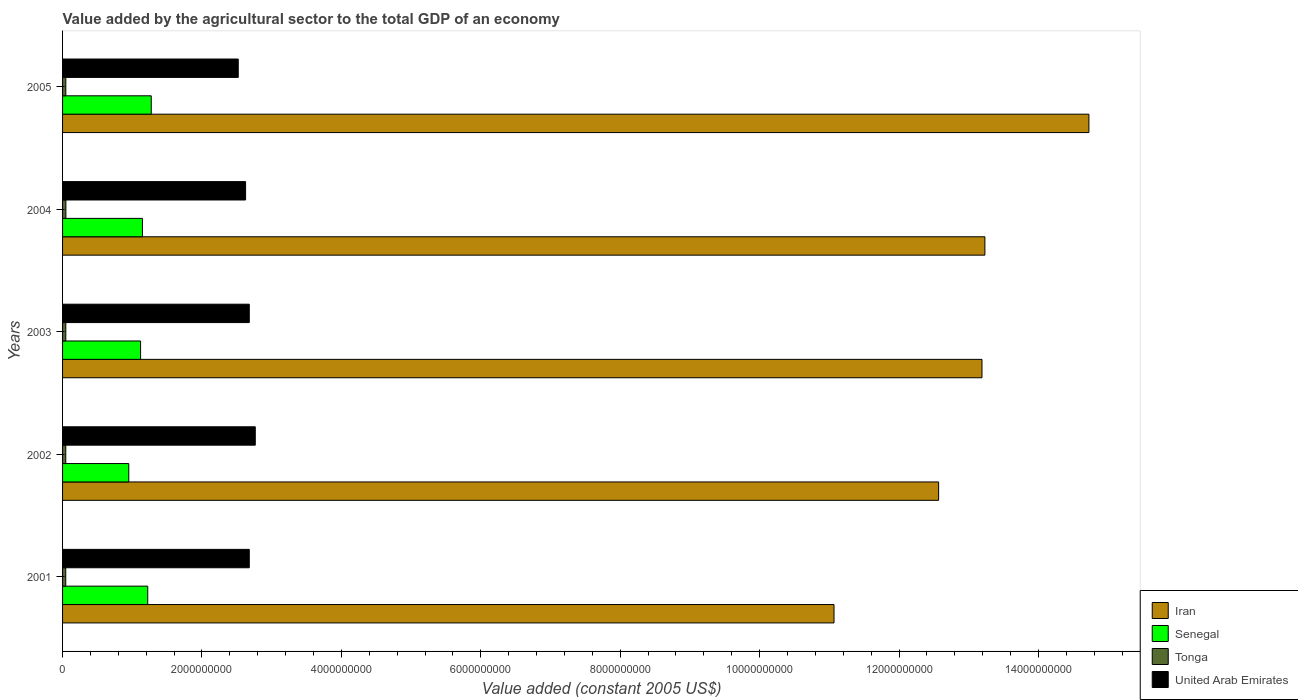How many different coloured bars are there?
Offer a very short reply. 4. Are the number of bars on each tick of the Y-axis equal?
Offer a terse response. Yes. What is the value added by the agricultural sector in United Arab Emirates in 2005?
Your response must be concise. 2.52e+09. Across all years, what is the maximum value added by the agricultural sector in Tonga?
Give a very brief answer. 4.76e+07. Across all years, what is the minimum value added by the agricultural sector in Iran?
Keep it short and to the point. 1.11e+1. In which year was the value added by the agricultural sector in Tonga maximum?
Give a very brief answer. 2004. In which year was the value added by the agricultural sector in Iran minimum?
Provide a succinct answer. 2001. What is the total value added by the agricultural sector in Iran in the graph?
Your answer should be compact. 6.48e+1. What is the difference between the value added by the agricultural sector in Senegal in 2003 and that in 2004?
Ensure brevity in your answer.  -2.67e+07. What is the difference between the value added by the agricultural sector in Senegal in 2005 and the value added by the agricultural sector in Iran in 2002?
Ensure brevity in your answer.  -1.13e+1. What is the average value added by the agricultural sector in Tonga per year?
Offer a very short reply. 4.65e+07. In the year 2001, what is the difference between the value added by the agricultural sector in Iran and value added by the agricultural sector in Tonga?
Provide a short and direct response. 1.10e+1. What is the ratio of the value added by the agricultural sector in Tonga in 2001 to that in 2002?
Your answer should be very brief. 0.99. What is the difference between the highest and the second highest value added by the agricultural sector in Iran?
Provide a succinct answer. 1.49e+09. What is the difference between the highest and the lowest value added by the agricultural sector in Tonga?
Provide a succinct answer. 1.84e+06. What does the 3rd bar from the top in 2004 represents?
Offer a very short reply. Senegal. What does the 1st bar from the bottom in 2004 represents?
Ensure brevity in your answer.  Iran. What is the difference between two consecutive major ticks on the X-axis?
Give a very brief answer. 2.00e+09. Are the values on the major ticks of X-axis written in scientific E-notation?
Offer a terse response. No. Does the graph contain any zero values?
Your response must be concise. No. Does the graph contain grids?
Ensure brevity in your answer.  No. How many legend labels are there?
Offer a very short reply. 4. How are the legend labels stacked?
Ensure brevity in your answer.  Vertical. What is the title of the graph?
Offer a terse response. Value added by the agricultural sector to the total GDP of an economy. Does "Ecuador" appear as one of the legend labels in the graph?
Ensure brevity in your answer.  No. What is the label or title of the X-axis?
Ensure brevity in your answer.  Value added (constant 2005 US$). What is the Value added (constant 2005 US$) of Iran in 2001?
Provide a short and direct response. 1.11e+1. What is the Value added (constant 2005 US$) of Senegal in 2001?
Your answer should be compact. 1.22e+09. What is the Value added (constant 2005 US$) in Tonga in 2001?
Your response must be concise. 4.58e+07. What is the Value added (constant 2005 US$) in United Arab Emirates in 2001?
Your response must be concise. 2.68e+09. What is the Value added (constant 2005 US$) in Iran in 2002?
Ensure brevity in your answer.  1.26e+1. What is the Value added (constant 2005 US$) in Senegal in 2002?
Make the answer very short. 9.50e+08. What is the Value added (constant 2005 US$) of Tonga in 2002?
Provide a succinct answer. 4.61e+07. What is the Value added (constant 2005 US$) in United Arab Emirates in 2002?
Make the answer very short. 2.76e+09. What is the Value added (constant 2005 US$) of Iran in 2003?
Offer a very short reply. 1.32e+1. What is the Value added (constant 2005 US$) of Senegal in 2003?
Your answer should be very brief. 1.12e+09. What is the Value added (constant 2005 US$) in Tonga in 2003?
Provide a short and direct response. 4.66e+07. What is the Value added (constant 2005 US$) in United Arab Emirates in 2003?
Ensure brevity in your answer.  2.68e+09. What is the Value added (constant 2005 US$) in Iran in 2004?
Keep it short and to the point. 1.32e+1. What is the Value added (constant 2005 US$) of Senegal in 2004?
Offer a very short reply. 1.15e+09. What is the Value added (constant 2005 US$) of Tonga in 2004?
Ensure brevity in your answer.  4.76e+07. What is the Value added (constant 2005 US$) of United Arab Emirates in 2004?
Offer a very short reply. 2.63e+09. What is the Value added (constant 2005 US$) in Iran in 2005?
Your response must be concise. 1.47e+1. What is the Value added (constant 2005 US$) in Senegal in 2005?
Provide a succinct answer. 1.27e+09. What is the Value added (constant 2005 US$) in Tonga in 2005?
Offer a very short reply. 4.66e+07. What is the Value added (constant 2005 US$) of United Arab Emirates in 2005?
Make the answer very short. 2.52e+09. Across all years, what is the maximum Value added (constant 2005 US$) of Iran?
Your answer should be compact. 1.47e+1. Across all years, what is the maximum Value added (constant 2005 US$) of Senegal?
Your response must be concise. 1.27e+09. Across all years, what is the maximum Value added (constant 2005 US$) of Tonga?
Your response must be concise. 4.76e+07. Across all years, what is the maximum Value added (constant 2005 US$) of United Arab Emirates?
Make the answer very short. 2.76e+09. Across all years, what is the minimum Value added (constant 2005 US$) of Iran?
Ensure brevity in your answer.  1.11e+1. Across all years, what is the minimum Value added (constant 2005 US$) in Senegal?
Provide a short and direct response. 9.50e+08. Across all years, what is the minimum Value added (constant 2005 US$) in Tonga?
Provide a succinct answer. 4.58e+07. Across all years, what is the minimum Value added (constant 2005 US$) in United Arab Emirates?
Provide a succinct answer. 2.52e+09. What is the total Value added (constant 2005 US$) of Iran in the graph?
Provide a succinct answer. 6.48e+1. What is the total Value added (constant 2005 US$) of Senegal in the graph?
Your answer should be compact. 5.71e+09. What is the total Value added (constant 2005 US$) in Tonga in the graph?
Provide a succinct answer. 2.33e+08. What is the total Value added (constant 2005 US$) of United Arab Emirates in the graph?
Keep it short and to the point. 1.33e+1. What is the difference between the Value added (constant 2005 US$) of Iran in 2001 and that in 2002?
Provide a short and direct response. -1.50e+09. What is the difference between the Value added (constant 2005 US$) of Senegal in 2001 and that in 2002?
Offer a terse response. 2.72e+08. What is the difference between the Value added (constant 2005 US$) of Tonga in 2001 and that in 2002?
Your response must be concise. -3.43e+05. What is the difference between the Value added (constant 2005 US$) in United Arab Emirates in 2001 and that in 2002?
Keep it short and to the point. -8.60e+07. What is the difference between the Value added (constant 2005 US$) of Iran in 2001 and that in 2003?
Your answer should be very brief. -2.12e+09. What is the difference between the Value added (constant 2005 US$) of Senegal in 2001 and that in 2003?
Provide a succinct answer. 1.02e+08. What is the difference between the Value added (constant 2005 US$) in Tonga in 2001 and that in 2003?
Offer a very short reply. -8.05e+05. What is the difference between the Value added (constant 2005 US$) in Iran in 2001 and that in 2004?
Give a very brief answer. -2.16e+09. What is the difference between the Value added (constant 2005 US$) of Senegal in 2001 and that in 2004?
Give a very brief answer. 7.58e+07. What is the difference between the Value added (constant 2005 US$) in Tonga in 2001 and that in 2004?
Offer a terse response. -1.84e+06. What is the difference between the Value added (constant 2005 US$) of United Arab Emirates in 2001 and that in 2004?
Make the answer very short. 5.28e+07. What is the difference between the Value added (constant 2005 US$) of Iran in 2001 and that in 2005?
Your answer should be compact. -3.66e+09. What is the difference between the Value added (constant 2005 US$) in Senegal in 2001 and that in 2005?
Give a very brief answer. -5.05e+07. What is the difference between the Value added (constant 2005 US$) of Tonga in 2001 and that in 2005?
Provide a succinct answer. -8.19e+05. What is the difference between the Value added (constant 2005 US$) in United Arab Emirates in 2001 and that in 2005?
Your answer should be very brief. 1.58e+08. What is the difference between the Value added (constant 2005 US$) of Iran in 2002 and that in 2003?
Offer a terse response. -6.22e+08. What is the difference between the Value added (constant 2005 US$) of Senegal in 2002 and that in 2003?
Your answer should be compact. -1.69e+08. What is the difference between the Value added (constant 2005 US$) in Tonga in 2002 and that in 2003?
Provide a succinct answer. -4.62e+05. What is the difference between the Value added (constant 2005 US$) in United Arab Emirates in 2002 and that in 2003?
Offer a terse response. 8.60e+07. What is the difference between the Value added (constant 2005 US$) in Iran in 2002 and that in 2004?
Your answer should be compact. -6.64e+08. What is the difference between the Value added (constant 2005 US$) of Senegal in 2002 and that in 2004?
Keep it short and to the point. -1.96e+08. What is the difference between the Value added (constant 2005 US$) in Tonga in 2002 and that in 2004?
Give a very brief answer. -1.49e+06. What is the difference between the Value added (constant 2005 US$) of United Arab Emirates in 2002 and that in 2004?
Provide a succinct answer. 1.39e+08. What is the difference between the Value added (constant 2005 US$) in Iran in 2002 and that in 2005?
Keep it short and to the point. -2.16e+09. What is the difference between the Value added (constant 2005 US$) in Senegal in 2002 and that in 2005?
Provide a succinct answer. -3.22e+08. What is the difference between the Value added (constant 2005 US$) in Tonga in 2002 and that in 2005?
Make the answer very short. -4.76e+05. What is the difference between the Value added (constant 2005 US$) of United Arab Emirates in 2002 and that in 2005?
Your answer should be compact. 2.44e+08. What is the difference between the Value added (constant 2005 US$) of Iran in 2003 and that in 2004?
Ensure brevity in your answer.  -4.16e+07. What is the difference between the Value added (constant 2005 US$) in Senegal in 2003 and that in 2004?
Your answer should be very brief. -2.67e+07. What is the difference between the Value added (constant 2005 US$) in Tonga in 2003 and that in 2004?
Ensure brevity in your answer.  -1.03e+06. What is the difference between the Value added (constant 2005 US$) in United Arab Emirates in 2003 and that in 2004?
Provide a succinct answer. 5.28e+07. What is the difference between the Value added (constant 2005 US$) in Iran in 2003 and that in 2005?
Provide a succinct answer. -1.53e+09. What is the difference between the Value added (constant 2005 US$) of Senegal in 2003 and that in 2005?
Make the answer very short. -1.53e+08. What is the difference between the Value added (constant 2005 US$) in Tonga in 2003 and that in 2005?
Offer a very short reply. -1.41e+04. What is the difference between the Value added (constant 2005 US$) in United Arab Emirates in 2003 and that in 2005?
Your response must be concise. 1.58e+08. What is the difference between the Value added (constant 2005 US$) in Iran in 2004 and that in 2005?
Your answer should be compact. -1.49e+09. What is the difference between the Value added (constant 2005 US$) in Senegal in 2004 and that in 2005?
Offer a very short reply. -1.26e+08. What is the difference between the Value added (constant 2005 US$) of Tonga in 2004 and that in 2005?
Your answer should be compact. 1.02e+06. What is the difference between the Value added (constant 2005 US$) of United Arab Emirates in 2004 and that in 2005?
Give a very brief answer. 1.06e+08. What is the difference between the Value added (constant 2005 US$) of Iran in 2001 and the Value added (constant 2005 US$) of Senegal in 2002?
Offer a terse response. 1.01e+1. What is the difference between the Value added (constant 2005 US$) of Iran in 2001 and the Value added (constant 2005 US$) of Tonga in 2002?
Your answer should be very brief. 1.10e+1. What is the difference between the Value added (constant 2005 US$) in Iran in 2001 and the Value added (constant 2005 US$) in United Arab Emirates in 2002?
Ensure brevity in your answer.  8.30e+09. What is the difference between the Value added (constant 2005 US$) of Senegal in 2001 and the Value added (constant 2005 US$) of Tonga in 2002?
Provide a short and direct response. 1.18e+09. What is the difference between the Value added (constant 2005 US$) of Senegal in 2001 and the Value added (constant 2005 US$) of United Arab Emirates in 2002?
Ensure brevity in your answer.  -1.54e+09. What is the difference between the Value added (constant 2005 US$) in Tonga in 2001 and the Value added (constant 2005 US$) in United Arab Emirates in 2002?
Your answer should be very brief. -2.72e+09. What is the difference between the Value added (constant 2005 US$) in Iran in 2001 and the Value added (constant 2005 US$) in Senegal in 2003?
Your answer should be compact. 9.95e+09. What is the difference between the Value added (constant 2005 US$) in Iran in 2001 and the Value added (constant 2005 US$) in Tonga in 2003?
Make the answer very short. 1.10e+1. What is the difference between the Value added (constant 2005 US$) of Iran in 2001 and the Value added (constant 2005 US$) of United Arab Emirates in 2003?
Make the answer very short. 8.39e+09. What is the difference between the Value added (constant 2005 US$) in Senegal in 2001 and the Value added (constant 2005 US$) in Tonga in 2003?
Keep it short and to the point. 1.18e+09. What is the difference between the Value added (constant 2005 US$) of Senegal in 2001 and the Value added (constant 2005 US$) of United Arab Emirates in 2003?
Provide a succinct answer. -1.46e+09. What is the difference between the Value added (constant 2005 US$) in Tonga in 2001 and the Value added (constant 2005 US$) in United Arab Emirates in 2003?
Give a very brief answer. -2.63e+09. What is the difference between the Value added (constant 2005 US$) of Iran in 2001 and the Value added (constant 2005 US$) of Senegal in 2004?
Ensure brevity in your answer.  9.92e+09. What is the difference between the Value added (constant 2005 US$) in Iran in 2001 and the Value added (constant 2005 US$) in Tonga in 2004?
Keep it short and to the point. 1.10e+1. What is the difference between the Value added (constant 2005 US$) of Iran in 2001 and the Value added (constant 2005 US$) of United Arab Emirates in 2004?
Offer a very short reply. 8.44e+09. What is the difference between the Value added (constant 2005 US$) in Senegal in 2001 and the Value added (constant 2005 US$) in Tonga in 2004?
Your answer should be compact. 1.17e+09. What is the difference between the Value added (constant 2005 US$) in Senegal in 2001 and the Value added (constant 2005 US$) in United Arab Emirates in 2004?
Keep it short and to the point. -1.40e+09. What is the difference between the Value added (constant 2005 US$) in Tonga in 2001 and the Value added (constant 2005 US$) in United Arab Emirates in 2004?
Provide a short and direct response. -2.58e+09. What is the difference between the Value added (constant 2005 US$) in Iran in 2001 and the Value added (constant 2005 US$) in Senegal in 2005?
Offer a terse response. 9.80e+09. What is the difference between the Value added (constant 2005 US$) of Iran in 2001 and the Value added (constant 2005 US$) of Tonga in 2005?
Make the answer very short. 1.10e+1. What is the difference between the Value added (constant 2005 US$) in Iran in 2001 and the Value added (constant 2005 US$) in United Arab Emirates in 2005?
Your answer should be compact. 8.55e+09. What is the difference between the Value added (constant 2005 US$) in Senegal in 2001 and the Value added (constant 2005 US$) in Tonga in 2005?
Provide a succinct answer. 1.18e+09. What is the difference between the Value added (constant 2005 US$) of Senegal in 2001 and the Value added (constant 2005 US$) of United Arab Emirates in 2005?
Your response must be concise. -1.30e+09. What is the difference between the Value added (constant 2005 US$) of Tonga in 2001 and the Value added (constant 2005 US$) of United Arab Emirates in 2005?
Provide a short and direct response. -2.47e+09. What is the difference between the Value added (constant 2005 US$) of Iran in 2002 and the Value added (constant 2005 US$) of Senegal in 2003?
Make the answer very short. 1.14e+1. What is the difference between the Value added (constant 2005 US$) in Iran in 2002 and the Value added (constant 2005 US$) in Tonga in 2003?
Give a very brief answer. 1.25e+1. What is the difference between the Value added (constant 2005 US$) of Iran in 2002 and the Value added (constant 2005 US$) of United Arab Emirates in 2003?
Your answer should be compact. 9.89e+09. What is the difference between the Value added (constant 2005 US$) in Senegal in 2002 and the Value added (constant 2005 US$) in Tonga in 2003?
Provide a succinct answer. 9.03e+08. What is the difference between the Value added (constant 2005 US$) of Senegal in 2002 and the Value added (constant 2005 US$) of United Arab Emirates in 2003?
Your answer should be very brief. -1.73e+09. What is the difference between the Value added (constant 2005 US$) of Tonga in 2002 and the Value added (constant 2005 US$) of United Arab Emirates in 2003?
Make the answer very short. -2.63e+09. What is the difference between the Value added (constant 2005 US$) in Iran in 2002 and the Value added (constant 2005 US$) in Senegal in 2004?
Your answer should be very brief. 1.14e+1. What is the difference between the Value added (constant 2005 US$) of Iran in 2002 and the Value added (constant 2005 US$) of Tonga in 2004?
Make the answer very short. 1.25e+1. What is the difference between the Value added (constant 2005 US$) of Iran in 2002 and the Value added (constant 2005 US$) of United Arab Emirates in 2004?
Your response must be concise. 9.94e+09. What is the difference between the Value added (constant 2005 US$) of Senegal in 2002 and the Value added (constant 2005 US$) of Tonga in 2004?
Keep it short and to the point. 9.02e+08. What is the difference between the Value added (constant 2005 US$) of Senegal in 2002 and the Value added (constant 2005 US$) of United Arab Emirates in 2004?
Give a very brief answer. -1.68e+09. What is the difference between the Value added (constant 2005 US$) in Tonga in 2002 and the Value added (constant 2005 US$) in United Arab Emirates in 2004?
Keep it short and to the point. -2.58e+09. What is the difference between the Value added (constant 2005 US$) of Iran in 2002 and the Value added (constant 2005 US$) of Senegal in 2005?
Provide a succinct answer. 1.13e+1. What is the difference between the Value added (constant 2005 US$) of Iran in 2002 and the Value added (constant 2005 US$) of Tonga in 2005?
Your response must be concise. 1.25e+1. What is the difference between the Value added (constant 2005 US$) in Iran in 2002 and the Value added (constant 2005 US$) in United Arab Emirates in 2005?
Offer a terse response. 1.00e+1. What is the difference between the Value added (constant 2005 US$) of Senegal in 2002 and the Value added (constant 2005 US$) of Tonga in 2005?
Provide a succinct answer. 9.03e+08. What is the difference between the Value added (constant 2005 US$) of Senegal in 2002 and the Value added (constant 2005 US$) of United Arab Emirates in 2005?
Offer a terse response. -1.57e+09. What is the difference between the Value added (constant 2005 US$) in Tonga in 2002 and the Value added (constant 2005 US$) in United Arab Emirates in 2005?
Keep it short and to the point. -2.47e+09. What is the difference between the Value added (constant 2005 US$) in Iran in 2003 and the Value added (constant 2005 US$) in Senegal in 2004?
Provide a short and direct response. 1.20e+1. What is the difference between the Value added (constant 2005 US$) in Iran in 2003 and the Value added (constant 2005 US$) in Tonga in 2004?
Offer a very short reply. 1.31e+1. What is the difference between the Value added (constant 2005 US$) in Iran in 2003 and the Value added (constant 2005 US$) in United Arab Emirates in 2004?
Keep it short and to the point. 1.06e+1. What is the difference between the Value added (constant 2005 US$) of Senegal in 2003 and the Value added (constant 2005 US$) of Tonga in 2004?
Make the answer very short. 1.07e+09. What is the difference between the Value added (constant 2005 US$) in Senegal in 2003 and the Value added (constant 2005 US$) in United Arab Emirates in 2004?
Keep it short and to the point. -1.51e+09. What is the difference between the Value added (constant 2005 US$) in Tonga in 2003 and the Value added (constant 2005 US$) in United Arab Emirates in 2004?
Give a very brief answer. -2.58e+09. What is the difference between the Value added (constant 2005 US$) of Iran in 2003 and the Value added (constant 2005 US$) of Senegal in 2005?
Give a very brief answer. 1.19e+1. What is the difference between the Value added (constant 2005 US$) of Iran in 2003 and the Value added (constant 2005 US$) of Tonga in 2005?
Your answer should be compact. 1.31e+1. What is the difference between the Value added (constant 2005 US$) of Iran in 2003 and the Value added (constant 2005 US$) of United Arab Emirates in 2005?
Make the answer very short. 1.07e+1. What is the difference between the Value added (constant 2005 US$) of Senegal in 2003 and the Value added (constant 2005 US$) of Tonga in 2005?
Keep it short and to the point. 1.07e+09. What is the difference between the Value added (constant 2005 US$) in Senegal in 2003 and the Value added (constant 2005 US$) in United Arab Emirates in 2005?
Your response must be concise. -1.40e+09. What is the difference between the Value added (constant 2005 US$) of Tonga in 2003 and the Value added (constant 2005 US$) of United Arab Emirates in 2005?
Keep it short and to the point. -2.47e+09. What is the difference between the Value added (constant 2005 US$) of Iran in 2004 and the Value added (constant 2005 US$) of Senegal in 2005?
Provide a succinct answer. 1.20e+1. What is the difference between the Value added (constant 2005 US$) of Iran in 2004 and the Value added (constant 2005 US$) of Tonga in 2005?
Your response must be concise. 1.32e+1. What is the difference between the Value added (constant 2005 US$) in Iran in 2004 and the Value added (constant 2005 US$) in United Arab Emirates in 2005?
Make the answer very short. 1.07e+1. What is the difference between the Value added (constant 2005 US$) in Senegal in 2004 and the Value added (constant 2005 US$) in Tonga in 2005?
Offer a very short reply. 1.10e+09. What is the difference between the Value added (constant 2005 US$) of Senegal in 2004 and the Value added (constant 2005 US$) of United Arab Emirates in 2005?
Offer a very short reply. -1.37e+09. What is the difference between the Value added (constant 2005 US$) of Tonga in 2004 and the Value added (constant 2005 US$) of United Arab Emirates in 2005?
Provide a short and direct response. -2.47e+09. What is the average Value added (constant 2005 US$) in Iran per year?
Give a very brief answer. 1.30e+1. What is the average Value added (constant 2005 US$) in Senegal per year?
Your answer should be very brief. 1.14e+09. What is the average Value added (constant 2005 US$) in Tonga per year?
Offer a terse response. 4.65e+07. What is the average Value added (constant 2005 US$) in United Arab Emirates per year?
Make the answer very short. 2.65e+09. In the year 2001, what is the difference between the Value added (constant 2005 US$) in Iran and Value added (constant 2005 US$) in Senegal?
Keep it short and to the point. 9.85e+09. In the year 2001, what is the difference between the Value added (constant 2005 US$) of Iran and Value added (constant 2005 US$) of Tonga?
Provide a succinct answer. 1.10e+1. In the year 2001, what is the difference between the Value added (constant 2005 US$) of Iran and Value added (constant 2005 US$) of United Arab Emirates?
Offer a terse response. 8.39e+09. In the year 2001, what is the difference between the Value added (constant 2005 US$) in Senegal and Value added (constant 2005 US$) in Tonga?
Give a very brief answer. 1.18e+09. In the year 2001, what is the difference between the Value added (constant 2005 US$) in Senegal and Value added (constant 2005 US$) in United Arab Emirates?
Make the answer very short. -1.46e+09. In the year 2001, what is the difference between the Value added (constant 2005 US$) of Tonga and Value added (constant 2005 US$) of United Arab Emirates?
Offer a very short reply. -2.63e+09. In the year 2002, what is the difference between the Value added (constant 2005 US$) of Iran and Value added (constant 2005 US$) of Senegal?
Your response must be concise. 1.16e+1. In the year 2002, what is the difference between the Value added (constant 2005 US$) in Iran and Value added (constant 2005 US$) in Tonga?
Offer a terse response. 1.25e+1. In the year 2002, what is the difference between the Value added (constant 2005 US$) in Iran and Value added (constant 2005 US$) in United Arab Emirates?
Offer a terse response. 9.80e+09. In the year 2002, what is the difference between the Value added (constant 2005 US$) of Senegal and Value added (constant 2005 US$) of Tonga?
Give a very brief answer. 9.04e+08. In the year 2002, what is the difference between the Value added (constant 2005 US$) of Senegal and Value added (constant 2005 US$) of United Arab Emirates?
Your response must be concise. -1.81e+09. In the year 2002, what is the difference between the Value added (constant 2005 US$) of Tonga and Value added (constant 2005 US$) of United Arab Emirates?
Your response must be concise. -2.72e+09. In the year 2003, what is the difference between the Value added (constant 2005 US$) in Iran and Value added (constant 2005 US$) in Senegal?
Keep it short and to the point. 1.21e+1. In the year 2003, what is the difference between the Value added (constant 2005 US$) of Iran and Value added (constant 2005 US$) of Tonga?
Keep it short and to the point. 1.31e+1. In the year 2003, what is the difference between the Value added (constant 2005 US$) in Iran and Value added (constant 2005 US$) in United Arab Emirates?
Offer a terse response. 1.05e+1. In the year 2003, what is the difference between the Value added (constant 2005 US$) of Senegal and Value added (constant 2005 US$) of Tonga?
Your answer should be very brief. 1.07e+09. In the year 2003, what is the difference between the Value added (constant 2005 US$) in Senegal and Value added (constant 2005 US$) in United Arab Emirates?
Your answer should be very brief. -1.56e+09. In the year 2003, what is the difference between the Value added (constant 2005 US$) in Tonga and Value added (constant 2005 US$) in United Arab Emirates?
Offer a very short reply. -2.63e+09. In the year 2004, what is the difference between the Value added (constant 2005 US$) of Iran and Value added (constant 2005 US$) of Senegal?
Ensure brevity in your answer.  1.21e+1. In the year 2004, what is the difference between the Value added (constant 2005 US$) in Iran and Value added (constant 2005 US$) in Tonga?
Provide a short and direct response. 1.32e+1. In the year 2004, what is the difference between the Value added (constant 2005 US$) of Iran and Value added (constant 2005 US$) of United Arab Emirates?
Ensure brevity in your answer.  1.06e+1. In the year 2004, what is the difference between the Value added (constant 2005 US$) of Senegal and Value added (constant 2005 US$) of Tonga?
Offer a very short reply. 1.10e+09. In the year 2004, what is the difference between the Value added (constant 2005 US$) of Senegal and Value added (constant 2005 US$) of United Arab Emirates?
Your answer should be compact. -1.48e+09. In the year 2004, what is the difference between the Value added (constant 2005 US$) of Tonga and Value added (constant 2005 US$) of United Arab Emirates?
Your answer should be compact. -2.58e+09. In the year 2005, what is the difference between the Value added (constant 2005 US$) of Iran and Value added (constant 2005 US$) of Senegal?
Provide a short and direct response. 1.35e+1. In the year 2005, what is the difference between the Value added (constant 2005 US$) of Iran and Value added (constant 2005 US$) of Tonga?
Offer a very short reply. 1.47e+1. In the year 2005, what is the difference between the Value added (constant 2005 US$) in Iran and Value added (constant 2005 US$) in United Arab Emirates?
Keep it short and to the point. 1.22e+1. In the year 2005, what is the difference between the Value added (constant 2005 US$) in Senegal and Value added (constant 2005 US$) in Tonga?
Make the answer very short. 1.23e+09. In the year 2005, what is the difference between the Value added (constant 2005 US$) of Senegal and Value added (constant 2005 US$) of United Arab Emirates?
Your response must be concise. -1.25e+09. In the year 2005, what is the difference between the Value added (constant 2005 US$) of Tonga and Value added (constant 2005 US$) of United Arab Emirates?
Provide a short and direct response. -2.47e+09. What is the ratio of the Value added (constant 2005 US$) in Iran in 2001 to that in 2002?
Provide a succinct answer. 0.88. What is the ratio of the Value added (constant 2005 US$) of Senegal in 2001 to that in 2002?
Offer a terse response. 1.29. What is the ratio of the Value added (constant 2005 US$) of Tonga in 2001 to that in 2002?
Provide a short and direct response. 0.99. What is the ratio of the Value added (constant 2005 US$) in United Arab Emirates in 2001 to that in 2002?
Offer a very short reply. 0.97. What is the ratio of the Value added (constant 2005 US$) of Iran in 2001 to that in 2003?
Provide a short and direct response. 0.84. What is the ratio of the Value added (constant 2005 US$) in Senegal in 2001 to that in 2003?
Offer a terse response. 1.09. What is the ratio of the Value added (constant 2005 US$) in Tonga in 2001 to that in 2003?
Provide a short and direct response. 0.98. What is the ratio of the Value added (constant 2005 US$) of United Arab Emirates in 2001 to that in 2003?
Offer a terse response. 1. What is the ratio of the Value added (constant 2005 US$) in Iran in 2001 to that in 2004?
Your answer should be very brief. 0.84. What is the ratio of the Value added (constant 2005 US$) in Senegal in 2001 to that in 2004?
Your answer should be very brief. 1.07. What is the ratio of the Value added (constant 2005 US$) in Tonga in 2001 to that in 2004?
Offer a terse response. 0.96. What is the ratio of the Value added (constant 2005 US$) of United Arab Emirates in 2001 to that in 2004?
Keep it short and to the point. 1.02. What is the ratio of the Value added (constant 2005 US$) in Iran in 2001 to that in 2005?
Offer a terse response. 0.75. What is the ratio of the Value added (constant 2005 US$) of Senegal in 2001 to that in 2005?
Offer a terse response. 0.96. What is the ratio of the Value added (constant 2005 US$) of Tonga in 2001 to that in 2005?
Give a very brief answer. 0.98. What is the ratio of the Value added (constant 2005 US$) of United Arab Emirates in 2001 to that in 2005?
Provide a succinct answer. 1.06. What is the ratio of the Value added (constant 2005 US$) in Iran in 2002 to that in 2003?
Your response must be concise. 0.95. What is the ratio of the Value added (constant 2005 US$) of Senegal in 2002 to that in 2003?
Make the answer very short. 0.85. What is the ratio of the Value added (constant 2005 US$) in United Arab Emirates in 2002 to that in 2003?
Your answer should be very brief. 1.03. What is the ratio of the Value added (constant 2005 US$) of Iran in 2002 to that in 2004?
Provide a succinct answer. 0.95. What is the ratio of the Value added (constant 2005 US$) in Senegal in 2002 to that in 2004?
Provide a short and direct response. 0.83. What is the ratio of the Value added (constant 2005 US$) of Tonga in 2002 to that in 2004?
Ensure brevity in your answer.  0.97. What is the ratio of the Value added (constant 2005 US$) of United Arab Emirates in 2002 to that in 2004?
Give a very brief answer. 1.05. What is the ratio of the Value added (constant 2005 US$) in Iran in 2002 to that in 2005?
Keep it short and to the point. 0.85. What is the ratio of the Value added (constant 2005 US$) of Senegal in 2002 to that in 2005?
Your answer should be compact. 0.75. What is the ratio of the Value added (constant 2005 US$) in Tonga in 2002 to that in 2005?
Keep it short and to the point. 0.99. What is the ratio of the Value added (constant 2005 US$) of United Arab Emirates in 2002 to that in 2005?
Your answer should be compact. 1.1. What is the ratio of the Value added (constant 2005 US$) in Senegal in 2003 to that in 2004?
Your answer should be very brief. 0.98. What is the ratio of the Value added (constant 2005 US$) in Tonga in 2003 to that in 2004?
Give a very brief answer. 0.98. What is the ratio of the Value added (constant 2005 US$) of United Arab Emirates in 2003 to that in 2004?
Give a very brief answer. 1.02. What is the ratio of the Value added (constant 2005 US$) in Iran in 2003 to that in 2005?
Your answer should be compact. 0.9. What is the ratio of the Value added (constant 2005 US$) in Senegal in 2003 to that in 2005?
Your answer should be very brief. 0.88. What is the ratio of the Value added (constant 2005 US$) of United Arab Emirates in 2003 to that in 2005?
Keep it short and to the point. 1.06. What is the ratio of the Value added (constant 2005 US$) of Iran in 2004 to that in 2005?
Keep it short and to the point. 0.9. What is the ratio of the Value added (constant 2005 US$) in Senegal in 2004 to that in 2005?
Offer a terse response. 0.9. What is the ratio of the Value added (constant 2005 US$) in Tonga in 2004 to that in 2005?
Make the answer very short. 1.02. What is the ratio of the Value added (constant 2005 US$) in United Arab Emirates in 2004 to that in 2005?
Offer a terse response. 1.04. What is the difference between the highest and the second highest Value added (constant 2005 US$) in Iran?
Keep it short and to the point. 1.49e+09. What is the difference between the highest and the second highest Value added (constant 2005 US$) in Senegal?
Make the answer very short. 5.05e+07. What is the difference between the highest and the second highest Value added (constant 2005 US$) in Tonga?
Keep it short and to the point. 1.02e+06. What is the difference between the highest and the second highest Value added (constant 2005 US$) in United Arab Emirates?
Give a very brief answer. 8.60e+07. What is the difference between the highest and the lowest Value added (constant 2005 US$) in Iran?
Offer a very short reply. 3.66e+09. What is the difference between the highest and the lowest Value added (constant 2005 US$) in Senegal?
Keep it short and to the point. 3.22e+08. What is the difference between the highest and the lowest Value added (constant 2005 US$) in Tonga?
Provide a short and direct response. 1.84e+06. What is the difference between the highest and the lowest Value added (constant 2005 US$) of United Arab Emirates?
Make the answer very short. 2.44e+08. 